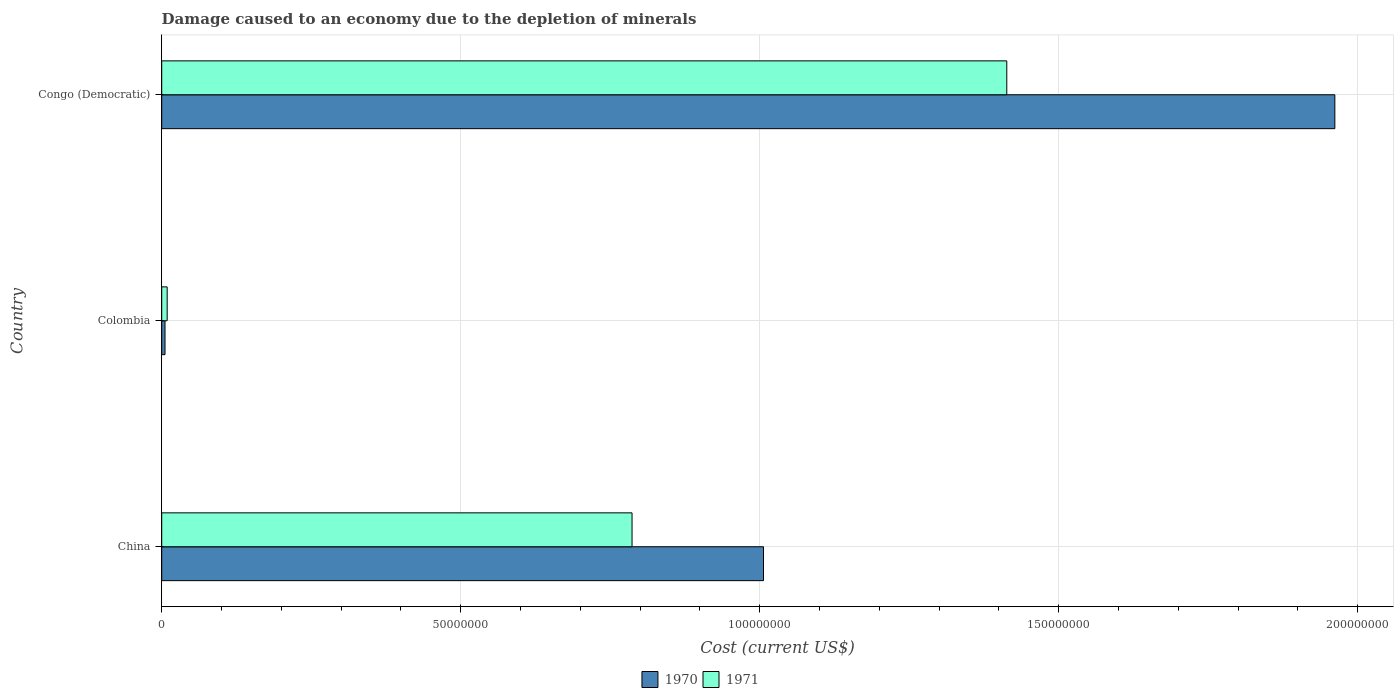Are the number of bars on each tick of the Y-axis equal?
Keep it short and to the point. Yes. How many bars are there on the 3rd tick from the top?
Keep it short and to the point. 2. What is the label of the 1st group of bars from the top?
Offer a terse response. Congo (Democratic). In how many cases, is the number of bars for a given country not equal to the number of legend labels?
Give a very brief answer. 0. What is the cost of damage caused due to the depletion of minerals in 1971 in Colombia?
Your response must be concise. 9.12e+05. Across all countries, what is the maximum cost of damage caused due to the depletion of minerals in 1970?
Provide a short and direct response. 1.96e+08. Across all countries, what is the minimum cost of damage caused due to the depletion of minerals in 1971?
Give a very brief answer. 9.12e+05. In which country was the cost of damage caused due to the depletion of minerals in 1970 maximum?
Offer a terse response. Congo (Democratic). What is the total cost of damage caused due to the depletion of minerals in 1971 in the graph?
Your response must be concise. 2.21e+08. What is the difference between the cost of damage caused due to the depletion of minerals in 1970 in Colombia and that in Congo (Democratic)?
Ensure brevity in your answer.  -1.96e+08. What is the difference between the cost of damage caused due to the depletion of minerals in 1971 in Congo (Democratic) and the cost of damage caused due to the depletion of minerals in 1970 in China?
Your response must be concise. 4.07e+07. What is the average cost of damage caused due to the depletion of minerals in 1970 per country?
Keep it short and to the point. 9.91e+07. What is the difference between the cost of damage caused due to the depletion of minerals in 1970 and cost of damage caused due to the depletion of minerals in 1971 in Colombia?
Give a very brief answer. -3.59e+05. In how many countries, is the cost of damage caused due to the depletion of minerals in 1971 greater than 130000000 US$?
Offer a terse response. 1. What is the ratio of the cost of damage caused due to the depletion of minerals in 1970 in China to that in Colombia?
Make the answer very short. 182.11. What is the difference between the highest and the second highest cost of damage caused due to the depletion of minerals in 1971?
Give a very brief answer. 6.27e+07. What is the difference between the highest and the lowest cost of damage caused due to the depletion of minerals in 1970?
Keep it short and to the point. 1.96e+08. What does the 2nd bar from the top in Colombia represents?
Your response must be concise. 1970. What does the 1st bar from the bottom in Congo (Democratic) represents?
Make the answer very short. 1970. How many bars are there?
Your answer should be compact. 6. How many countries are there in the graph?
Offer a very short reply. 3. Are the values on the major ticks of X-axis written in scientific E-notation?
Provide a short and direct response. No. Where does the legend appear in the graph?
Your answer should be very brief. Bottom center. How many legend labels are there?
Offer a terse response. 2. How are the legend labels stacked?
Provide a succinct answer. Horizontal. What is the title of the graph?
Your answer should be compact. Damage caused to an economy due to the depletion of minerals. Does "1985" appear as one of the legend labels in the graph?
Your answer should be very brief. No. What is the label or title of the X-axis?
Offer a terse response. Cost (current US$). What is the Cost (current US$) of 1970 in China?
Offer a terse response. 1.01e+08. What is the Cost (current US$) in 1971 in China?
Make the answer very short. 7.87e+07. What is the Cost (current US$) in 1970 in Colombia?
Offer a very short reply. 5.53e+05. What is the Cost (current US$) of 1971 in Colombia?
Give a very brief answer. 9.12e+05. What is the Cost (current US$) in 1970 in Congo (Democratic)?
Give a very brief answer. 1.96e+08. What is the Cost (current US$) of 1971 in Congo (Democratic)?
Provide a short and direct response. 1.41e+08. Across all countries, what is the maximum Cost (current US$) in 1970?
Make the answer very short. 1.96e+08. Across all countries, what is the maximum Cost (current US$) in 1971?
Your answer should be very brief. 1.41e+08. Across all countries, what is the minimum Cost (current US$) in 1970?
Ensure brevity in your answer.  5.53e+05. Across all countries, what is the minimum Cost (current US$) in 1971?
Your answer should be compact. 9.12e+05. What is the total Cost (current US$) of 1970 in the graph?
Offer a terse response. 2.97e+08. What is the total Cost (current US$) in 1971 in the graph?
Your answer should be very brief. 2.21e+08. What is the difference between the Cost (current US$) in 1970 in China and that in Colombia?
Provide a succinct answer. 1.00e+08. What is the difference between the Cost (current US$) of 1971 in China and that in Colombia?
Keep it short and to the point. 7.77e+07. What is the difference between the Cost (current US$) of 1970 in China and that in Congo (Democratic)?
Ensure brevity in your answer.  -9.55e+07. What is the difference between the Cost (current US$) of 1971 in China and that in Congo (Democratic)?
Make the answer very short. -6.27e+07. What is the difference between the Cost (current US$) of 1970 in Colombia and that in Congo (Democratic)?
Offer a very short reply. -1.96e+08. What is the difference between the Cost (current US$) in 1971 in Colombia and that in Congo (Democratic)?
Offer a terse response. -1.40e+08. What is the difference between the Cost (current US$) of 1970 in China and the Cost (current US$) of 1971 in Colombia?
Your response must be concise. 9.97e+07. What is the difference between the Cost (current US$) of 1970 in China and the Cost (current US$) of 1971 in Congo (Democratic)?
Ensure brevity in your answer.  -4.07e+07. What is the difference between the Cost (current US$) in 1970 in Colombia and the Cost (current US$) in 1971 in Congo (Democratic)?
Offer a terse response. -1.41e+08. What is the average Cost (current US$) in 1970 per country?
Provide a succinct answer. 9.91e+07. What is the average Cost (current US$) of 1971 per country?
Your answer should be compact. 7.36e+07. What is the difference between the Cost (current US$) in 1970 and Cost (current US$) in 1971 in China?
Give a very brief answer. 2.20e+07. What is the difference between the Cost (current US$) of 1970 and Cost (current US$) of 1971 in Colombia?
Provide a short and direct response. -3.59e+05. What is the difference between the Cost (current US$) in 1970 and Cost (current US$) in 1971 in Congo (Democratic)?
Ensure brevity in your answer.  5.49e+07. What is the ratio of the Cost (current US$) in 1970 in China to that in Colombia?
Keep it short and to the point. 182.11. What is the ratio of the Cost (current US$) of 1971 in China to that in Colombia?
Your answer should be very brief. 86.24. What is the ratio of the Cost (current US$) of 1970 in China to that in Congo (Democratic)?
Keep it short and to the point. 0.51. What is the ratio of the Cost (current US$) of 1971 in China to that in Congo (Democratic)?
Make the answer very short. 0.56. What is the ratio of the Cost (current US$) in 1970 in Colombia to that in Congo (Democratic)?
Make the answer very short. 0. What is the ratio of the Cost (current US$) in 1971 in Colombia to that in Congo (Democratic)?
Ensure brevity in your answer.  0.01. What is the difference between the highest and the second highest Cost (current US$) in 1970?
Provide a short and direct response. 9.55e+07. What is the difference between the highest and the second highest Cost (current US$) of 1971?
Give a very brief answer. 6.27e+07. What is the difference between the highest and the lowest Cost (current US$) of 1970?
Provide a short and direct response. 1.96e+08. What is the difference between the highest and the lowest Cost (current US$) in 1971?
Your response must be concise. 1.40e+08. 